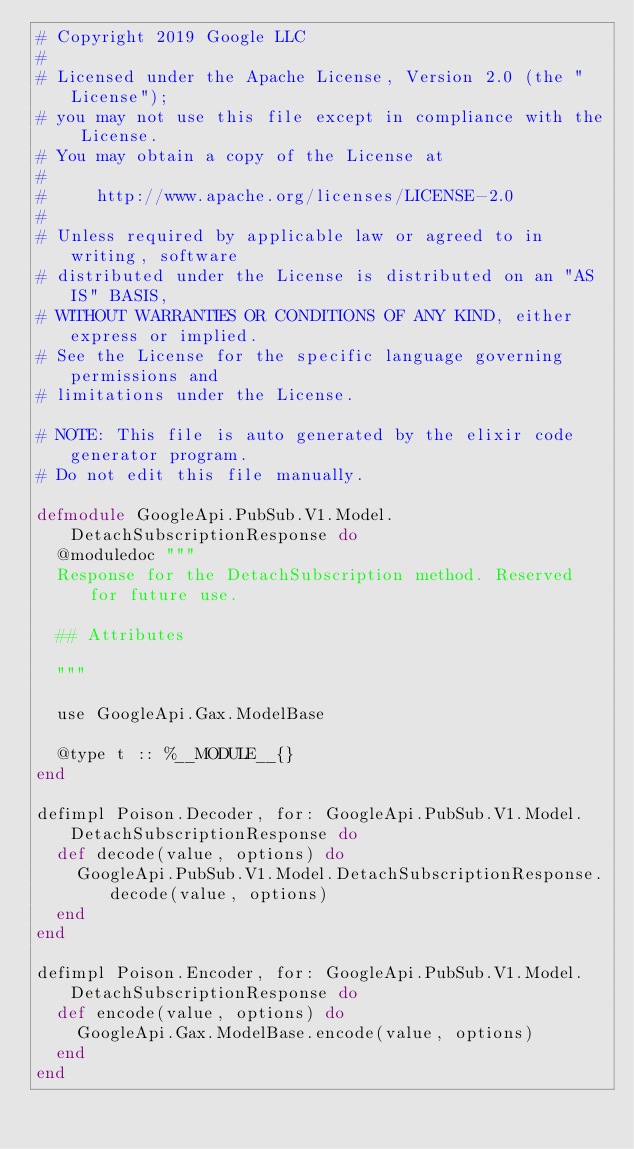<code> <loc_0><loc_0><loc_500><loc_500><_Elixir_># Copyright 2019 Google LLC
#
# Licensed under the Apache License, Version 2.0 (the "License");
# you may not use this file except in compliance with the License.
# You may obtain a copy of the License at
#
#     http://www.apache.org/licenses/LICENSE-2.0
#
# Unless required by applicable law or agreed to in writing, software
# distributed under the License is distributed on an "AS IS" BASIS,
# WITHOUT WARRANTIES OR CONDITIONS OF ANY KIND, either express or implied.
# See the License for the specific language governing permissions and
# limitations under the License.

# NOTE: This file is auto generated by the elixir code generator program.
# Do not edit this file manually.

defmodule GoogleApi.PubSub.V1.Model.DetachSubscriptionResponse do
  @moduledoc """
  Response for the DetachSubscription method. Reserved for future use.

  ## Attributes

  """

  use GoogleApi.Gax.ModelBase

  @type t :: %__MODULE__{}
end

defimpl Poison.Decoder, for: GoogleApi.PubSub.V1.Model.DetachSubscriptionResponse do
  def decode(value, options) do
    GoogleApi.PubSub.V1.Model.DetachSubscriptionResponse.decode(value, options)
  end
end

defimpl Poison.Encoder, for: GoogleApi.PubSub.V1.Model.DetachSubscriptionResponse do
  def encode(value, options) do
    GoogleApi.Gax.ModelBase.encode(value, options)
  end
end
</code> 